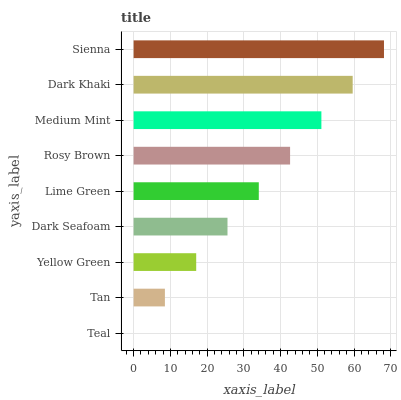Is Teal the minimum?
Answer yes or no. Yes. Is Sienna the maximum?
Answer yes or no. Yes. Is Tan the minimum?
Answer yes or no. No. Is Tan the maximum?
Answer yes or no. No. Is Tan greater than Teal?
Answer yes or no. Yes. Is Teal less than Tan?
Answer yes or no. Yes. Is Teal greater than Tan?
Answer yes or no. No. Is Tan less than Teal?
Answer yes or no. No. Is Lime Green the high median?
Answer yes or no. Yes. Is Lime Green the low median?
Answer yes or no. Yes. Is Dark Seafoam the high median?
Answer yes or no. No. Is Dark Khaki the low median?
Answer yes or no. No. 